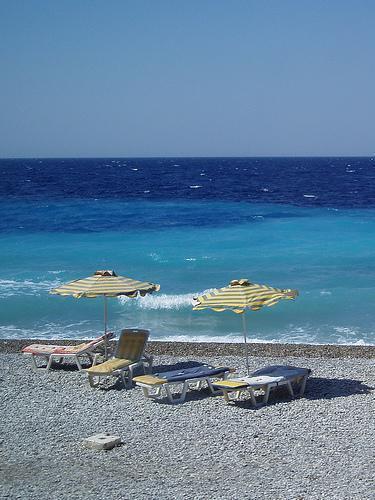How many lounge chairs are in this picture?
Give a very brief answer. 4. How many umbrellas are in the picture?
Give a very brief answer. 2. How many people are in this picture?
Give a very brief answer. 0. 